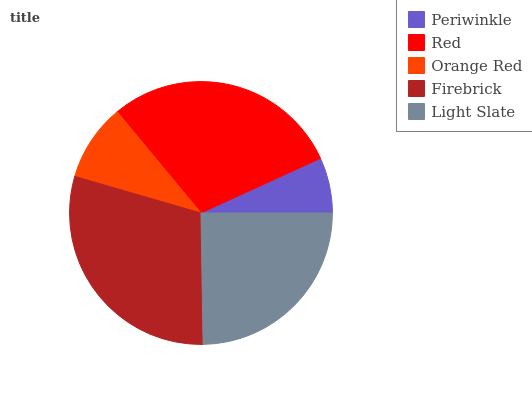Is Periwinkle the minimum?
Answer yes or no. Yes. Is Firebrick the maximum?
Answer yes or no. Yes. Is Red the minimum?
Answer yes or no. No. Is Red the maximum?
Answer yes or no. No. Is Red greater than Periwinkle?
Answer yes or no. Yes. Is Periwinkle less than Red?
Answer yes or no. Yes. Is Periwinkle greater than Red?
Answer yes or no. No. Is Red less than Periwinkle?
Answer yes or no. No. Is Light Slate the high median?
Answer yes or no. Yes. Is Light Slate the low median?
Answer yes or no. Yes. Is Red the high median?
Answer yes or no. No. Is Periwinkle the low median?
Answer yes or no. No. 